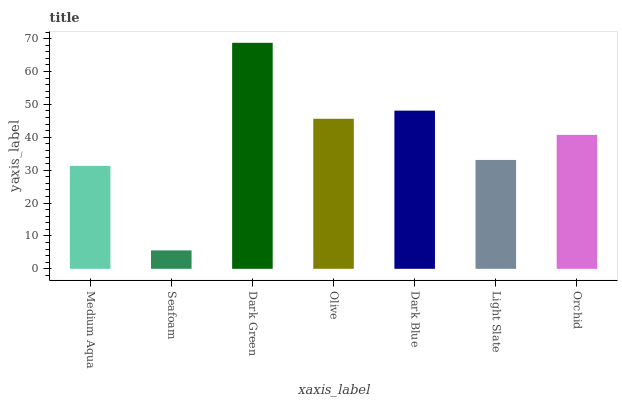Is Seafoam the minimum?
Answer yes or no. Yes. Is Dark Green the maximum?
Answer yes or no. Yes. Is Dark Green the minimum?
Answer yes or no. No. Is Seafoam the maximum?
Answer yes or no. No. Is Dark Green greater than Seafoam?
Answer yes or no. Yes. Is Seafoam less than Dark Green?
Answer yes or no. Yes. Is Seafoam greater than Dark Green?
Answer yes or no. No. Is Dark Green less than Seafoam?
Answer yes or no. No. Is Orchid the high median?
Answer yes or no. Yes. Is Orchid the low median?
Answer yes or no. Yes. Is Seafoam the high median?
Answer yes or no. No. Is Dark Blue the low median?
Answer yes or no. No. 